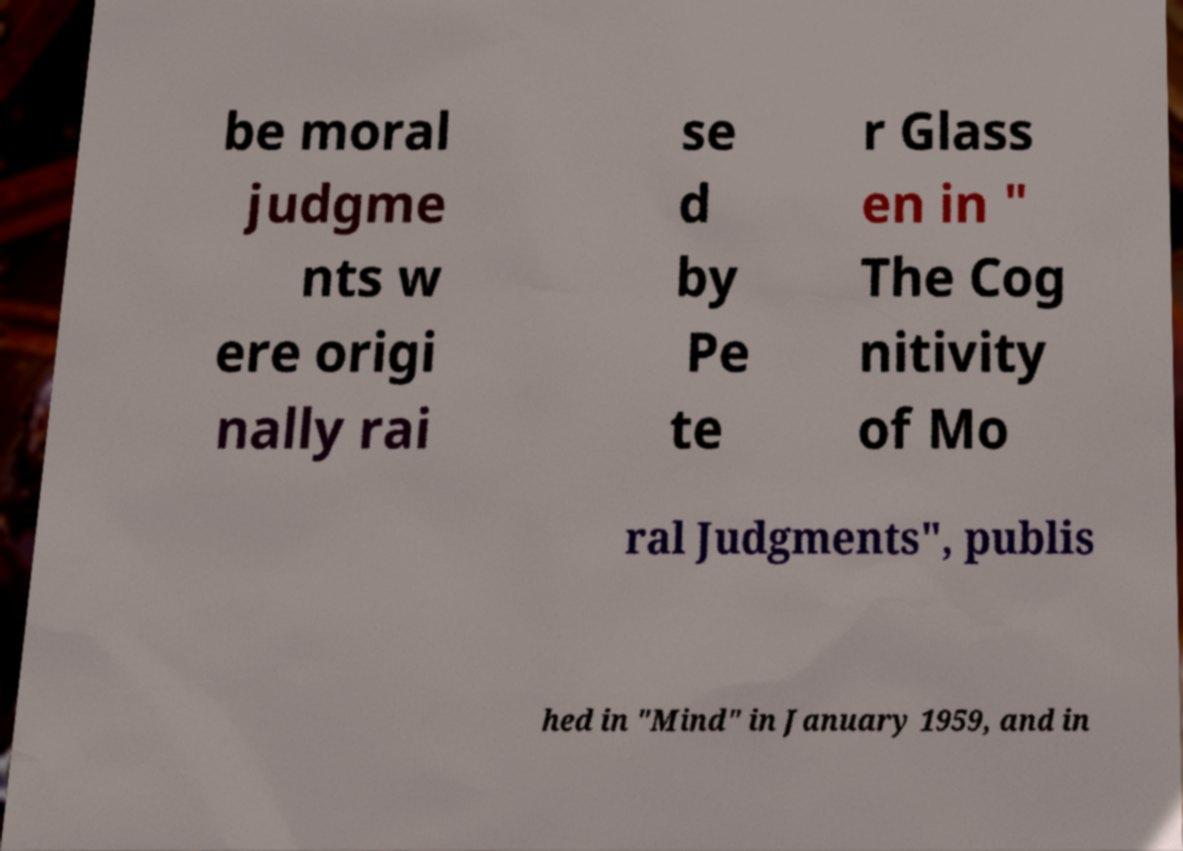Please identify and transcribe the text found in this image. be moral judgme nts w ere origi nally rai se d by Pe te r Glass en in " The Cog nitivity of Mo ral Judgments", publis hed in "Mind" in January 1959, and in 